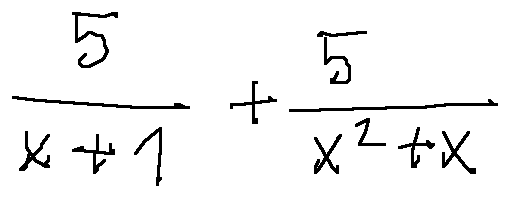<formula> <loc_0><loc_0><loc_500><loc_500>\frac { 5 } { x + 1 } + \frac { 5 } { x ^ { 2 } + x }</formula> 